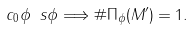<formula> <loc_0><loc_0><loc_500><loc_500>c _ { 0 } \phi \ s \phi \Longrightarrow \# \Pi _ { \phi } ( M ^ { \prime } ) = 1 .</formula> 